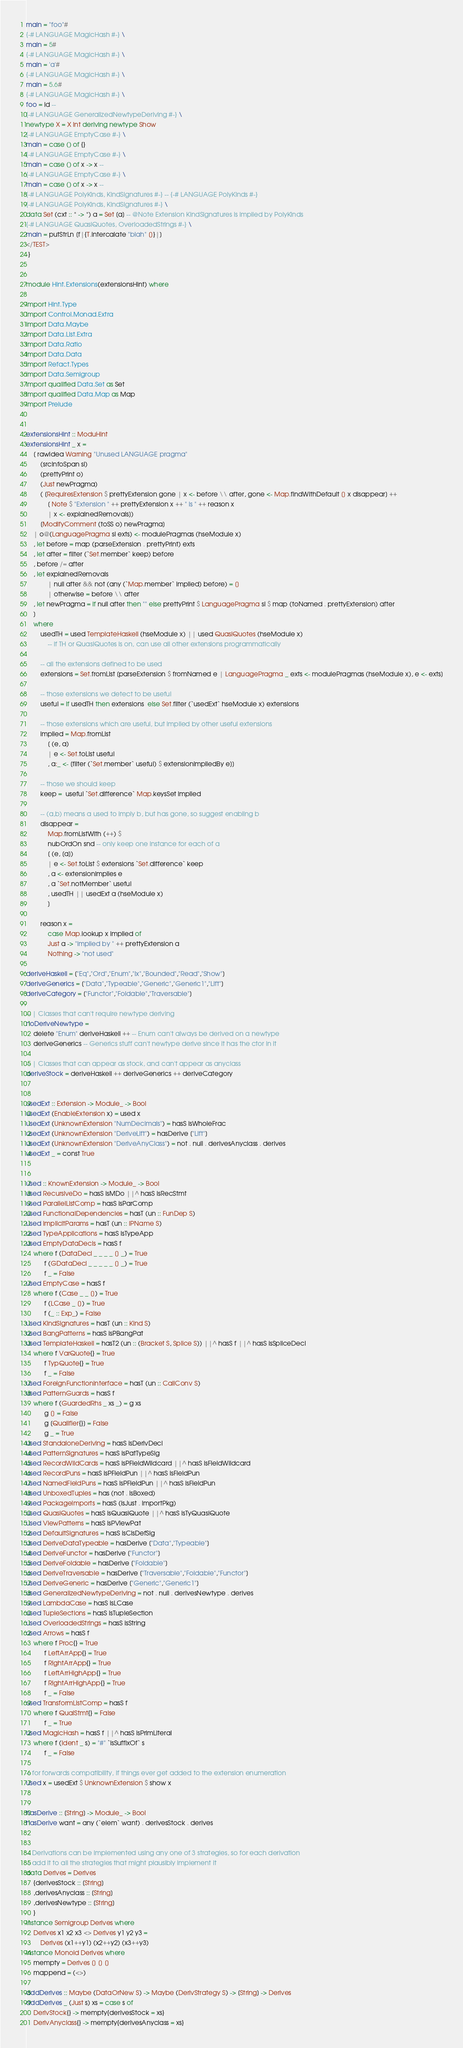Convert code to text. <code><loc_0><loc_0><loc_500><loc_500><_Haskell_>main = "foo"#
{-# LANGUAGE MagicHash #-} \
main = 5#
{-# LANGUAGE MagicHash #-} \
main = 'a'#
{-# LANGUAGE MagicHash #-} \
main = 5.6#
{-# LANGUAGE MagicHash #-} \
foo = id --
{-# LANGUAGE GeneralizedNewtypeDeriving #-} \
newtype X = X Int deriving newtype Show
{-# LANGUAGE EmptyCase #-} \
main = case () of {}
{-# LANGUAGE EmptyCase #-} \
main = case () of x -> x --
{-# LANGUAGE EmptyCase #-} \
main = case () of x -> x --
{-# LANGUAGE PolyKinds, KindSignatures #-} -- {-# LANGUAGE PolyKinds #-}
{-# LANGUAGE PolyKinds, KindSignatures #-} \
data Set (cxt :: * -> *) a = Set [a] -- @Note Extension KindSignatures is implied by PolyKinds
{-# LANGUAGE QuasiQuotes, OverloadedStrings #-} \
main = putStrLn [f|{T.intercalate "blah" []}|]
</TEST>
-}


module Hint.Extensions(extensionsHint) where

import Hint.Type
import Control.Monad.Extra
import Data.Maybe
import Data.List.Extra
import Data.Ratio
import Data.Data
import Refact.Types
import Data.Semigroup
import qualified Data.Set as Set
import qualified Data.Map as Map
import Prelude


extensionsHint :: ModuHint
extensionsHint _ x =
    [ rawIdea Warning "Unused LANGUAGE pragma"
        (srcInfoSpan sl)
        (prettyPrint o)
        (Just newPragma)
        ( [RequiresExtension $ prettyExtension gone | x <- before \\ after, gone <- Map.findWithDefault [] x disappear] ++
            [ Note $ "Extension " ++ prettyExtension x ++ " is " ++ reason x
            | x <- explainedRemovals])
        [ModifyComment (toSS o) newPragma]
    | o@(LanguagePragma sl exts) <- modulePragmas (hseModule x)
    , let before = map (parseExtension . prettyPrint) exts
    , let after = filter (`Set.member` keep) before
    , before /= after
    , let explainedRemovals
            | null after && not (any (`Map.member` implied) before) = []
            | otherwise = before \\ after
    , let newPragma = if null after then "" else prettyPrint $ LanguagePragma sl $ map (toNamed . prettyExtension) after
    ]
    where
        usedTH = used TemplateHaskell (hseModule x) || used QuasiQuotes (hseModule x)
            -- if TH or QuasiQuotes is on, can use all other extensions programmatically

        -- all the extensions defined to be used
        extensions = Set.fromList [parseExtension $ fromNamed e | LanguagePragma _ exts <- modulePragmas (hseModule x), e <- exts]

        -- those extensions we detect to be useful
        useful = if usedTH then extensions  else Set.filter (`usedExt` hseModule x) extensions

        -- those extensions which are useful, but implied by other useful extensions
        implied = Map.fromList
            [ (e, a)
            | e <- Set.toList useful
            , a:_ <- [filter (`Set.member` useful) $ extensionImpliedBy e]]

        -- those we should keep
        keep =  useful `Set.difference` Map.keysSet implied

        -- (a,b) means a used to imply b, but has gone, so suggest enabling b
        disappear =
            Map.fromListWith (++) $
            nubOrdOn snd -- only keep one instance for each of a
            [ (e, [a])
            | e <- Set.toList $ extensions `Set.difference` keep
            , a <- extensionImplies e
            , a `Set.notMember` useful
            , usedTH || usedExt a (hseModule x)
            ]

        reason x =
            case Map.lookup x implied of
            Just a -> "implied by " ++ prettyExtension a
            Nothing -> "not used"

deriveHaskell = ["Eq","Ord","Enum","Ix","Bounded","Read","Show"]
deriveGenerics = ["Data","Typeable","Generic","Generic1","Lift"]
deriveCategory = ["Functor","Foldable","Traversable"]

-- | Classes that can't require newtype deriving
noDeriveNewtype =
    delete "Enum" deriveHaskell ++ -- Enum can't always be derived on a newtype
    deriveGenerics -- Generics stuff can't newtype derive since it has the ctor in it

-- | Classes that can appear as stock, and can't appear as anyclass
deriveStock = deriveHaskell ++ deriveGenerics ++ deriveCategory


usedExt :: Extension -> Module_ -> Bool
usedExt (EnableExtension x) = used x
usedExt (UnknownExtension "NumDecimals") = hasS isWholeFrac
usedExt (UnknownExtension "DeriveLift") = hasDerive ["Lift"]
usedExt (UnknownExtension "DeriveAnyClass") = not . null . derivesAnyclass . derives
usedExt _ = const True


used :: KnownExtension -> Module_ -> Bool
used RecursiveDo = hasS isMDo ||^ hasS isRecStmt
used ParallelListComp = hasS isParComp
used FunctionalDependencies = hasT (un :: FunDep S)
used ImplicitParams = hasT (un :: IPName S)
used TypeApplications = hasS isTypeApp
used EmptyDataDecls = hasS f
    where f (DataDecl _ _ _ _ [] _) = True
          f (GDataDecl _ _ _ _ _ [] _) = True
          f _ = False
used EmptyCase = hasS f
    where f (Case _ _ []) = True
          f (LCase _ []) = True
          f (_ :: Exp_) = False
used KindSignatures = hasT (un :: Kind S)
used BangPatterns = hasS isPBangPat
used TemplateHaskell = hasT2 (un :: (Bracket S, Splice S)) ||^ hasS f ||^ hasS isSpliceDecl
    where f VarQuote{} = True
          f TypQuote{} = True
          f _ = False
used ForeignFunctionInterface = hasT (un :: CallConv S)
used PatternGuards = hasS f
    where f (GuardedRhs _ xs _) = g xs
          g [] = False
          g [Qualifier{}] = False
          g _ = True
used StandaloneDeriving = hasS isDerivDecl
used PatternSignatures = hasS isPatTypeSig
used RecordWildCards = hasS isPFieldWildcard ||^ hasS isFieldWildcard
used RecordPuns = hasS isPFieldPun ||^ hasS isFieldPun
used NamedFieldPuns = hasS isPFieldPun ||^ hasS isFieldPun
used UnboxedTuples = has (not . isBoxed)
used PackageImports = hasS (isJust . importPkg)
used QuasiQuotes = hasS isQuasiQuote ||^ hasS isTyQuasiQuote
used ViewPatterns = hasS isPViewPat
used DefaultSignatures = hasS isClsDefSig
used DeriveDataTypeable = hasDerive ["Data","Typeable"]
used DeriveFunctor = hasDerive ["Functor"]
used DeriveFoldable = hasDerive ["Foldable"]
used DeriveTraversable = hasDerive ["Traversable","Foldable","Functor"]
used DeriveGeneric = hasDerive ["Generic","Generic1"]
used GeneralizedNewtypeDeriving = not . null . derivesNewtype . derives
used LambdaCase = hasS isLCase
used TupleSections = hasS isTupleSection
used OverloadedStrings = hasS isString
used Arrows = hasS f
    where f Proc{} = True
          f LeftArrApp{} = True
          f RightArrApp{} = True
          f LeftArrHighApp{} = True
          f RightArrHighApp{} = True
          f _ = False
used TransformListComp = hasS f
    where f QualStmt{} = False
          f _ = True
used MagicHash = hasS f ||^ hasS isPrimLiteral
    where f (Ident _ s) = "#" `isSuffixOf` s
          f _ = False

-- for forwards compatibility, if things ever get added to the extension enumeration
used x = usedExt $ UnknownExtension $ show x


hasDerive :: [String] -> Module_ -> Bool
hasDerive want = any (`elem` want) . derivesStock . derives


-- Derivations can be implemented using any one of 3 strategies, so for each derivation
-- add it to all the strategies that might plausibly implement it
data Derives = Derives
    {derivesStock :: [String]
    ,derivesAnyclass :: [String]
    ,derivesNewtype :: [String]
    }
instance Semigroup Derives where
    Derives x1 x2 x3 <> Derives y1 y2 y3 =
        Derives (x1++y1) (x2++y2) (x3++y3)
instance Monoid Derives where
    mempty = Derives [] [] []
    mappend = (<>)

addDerives :: Maybe (DataOrNew S) -> Maybe (DerivStrategy S) -> [String] -> Derives
addDerives _ (Just s) xs = case s of
    DerivStock{} -> mempty{derivesStock = xs}
    DerivAnyclass{} -> mempty{derivesAnyclass = xs}</code> 